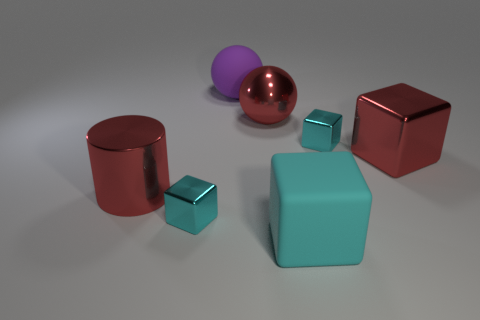Subtract all blue balls. How many cyan blocks are left? 3 Add 1 small yellow shiny cylinders. How many objects exist? 8 Subtract all cylinders. How many objects are left? 6 Subtract all small cyan cylinders. Subtract all large cyan rubber objects. How many objects are left? 6 Add 3 tiny cyan metallic blocks. How many tiny cyan metallic blocks are left? 5 Add 4 cyan shiny objects. How many cyan shiny objects exist? 6 Subtract 0 gray spheres. How many objects are left? 7 